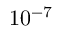Convert formula to latex. <formula><loc_0><loc_0><loc_500><loc_500>1 0 ^ { - 7 }</formula> 